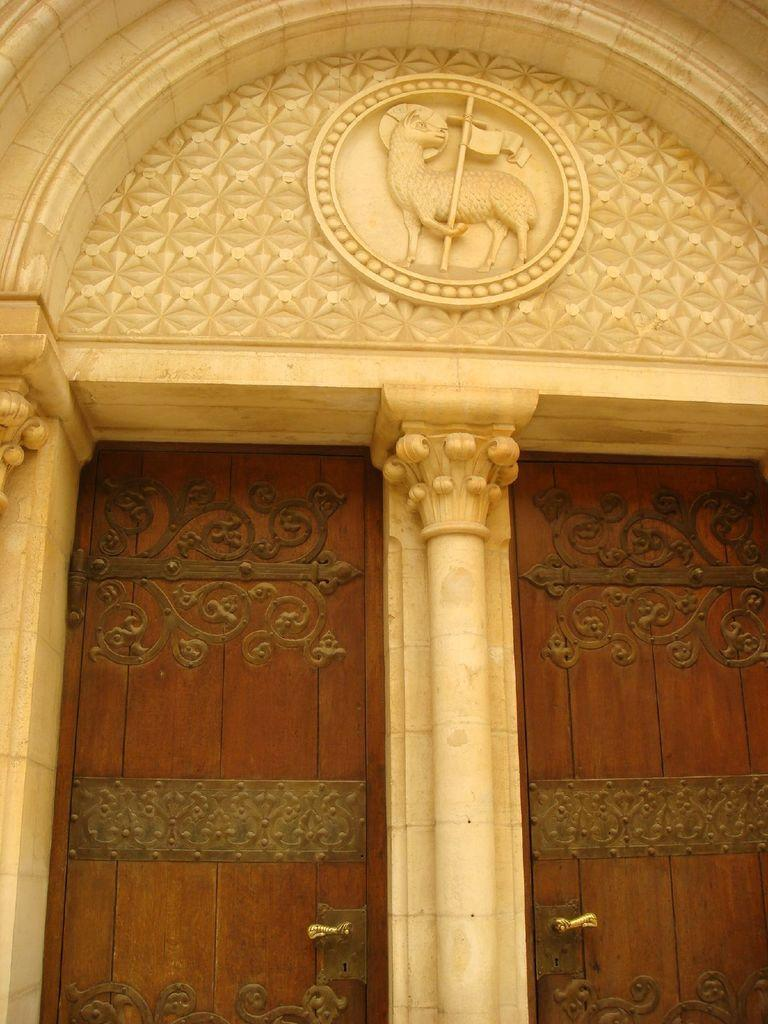What is depicted in the image? The image shows the entrance of a building. How many doors are there to enter the building? There are two doors to enter the building. Is there anything separating the doors? Yes, the doors are separated by a pillar. What type of coal is being used to generate electricity in the image? There is no coal or electricity generation visible in the image; it shows the entrance of a building with two doors separated by a pillar. 